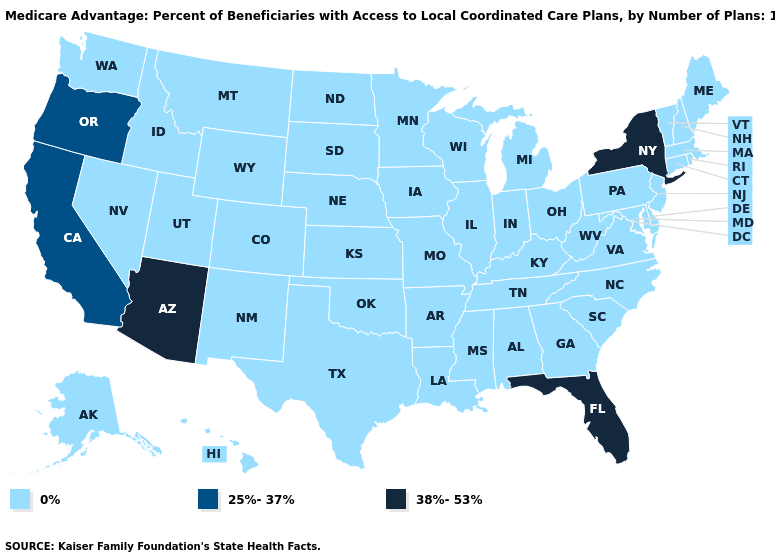Name the states that have a value in the range 38%-53%?
Concise answer only. Arizona, Florida, New York. Among the states that border Nebraska , which have the lowest value?
Write a very short answer. Colorado, Iowa, Kansas, Missouri, South Dakota, Wyoming. What is the value of Oklahoma?
Concise answer only. 0%. Does Washington have a lower value than California?
Quick response, please. Yes. What is the lowest value in states that border Oregon?
Keep it brief. 0%. What is the value of Vermont?
Give a very brief answer. 0%. Name the states that have a value in the range 0%?
Give a very brief answer. Alaska, Alabama, Arkansas, Colorado, Connecticut, Delaware, Georgia, Hawaii, Iowa, Idaho, Illinois, Indiana, Kansas, Kentucky, Louisiana, Massachusetts, Maryland, Maine, Michigan, Minnesota, Missouri, Mississippi, Montana, North Carolina, North Dakota, Nebraska, New Hampshire, New Jersey, New Mexico, Nevada, Ohio, Oklahoma, Pennsylvania, Rhode Island, South Carolina, South Dakota, Tennessee, Texas, Utah, Virginia, Vermont, Washington, Wisconsin, West Virginia, Wyoming. Name the states that have a value in the range 25%-37%?
Be succinct. California, Oregon. What is the highest value in the USA?
Write a very short answer. 38%-53%. Name the states that have a value in the range 0%?
Short answer required. Alaska, Alabama, Arkansas, Colorado, Connecticut, Delaware, Georgia, Hawaii, Iowa, Idaho, Illinois, Indiana, Kansas, Kentucky, Louisiana, Massachusetts, Maryland, Maine, Michigan, Minnesota, Missouri, Mississippi, Montana, North Carolina, North Dakota, Nebraska, New Hampshire, New Jersey, New Mexico, Nevada, Ohio, Oklahoma, Pennsylvania, Rhode Island, South Carolina, South Dakota, Tennessee, Texas, Utah, Virginia, Vermont, Washington, Wisconsin, West Virginia, Wyoming. Which states have the lowest value in the USA?
Be succinct. Alaska, Alabama, Arkansas, Colorado, Connecticut, Delaware, Georgia, Hawaii, Iowa, Idaho, Illinois, Indiana, Kansas, Kentucky, Louisiana, Massachusetts, Maryland, Maine, Michigan, Minnesota, Missouri, Mississippi, Montana, North Carolina, North Dakota, Nebraska, New Hampshire, New Jersey, New Mexico, Nevada, Ohio, Oklahoma, Pennsylvania, Rhode Island, South Carolina, South Dakota, Tennessee, Texas, Utah, Virginia, Vermont, Washington, Wisconsin, West Virginia, Wyoming. What is the value of South Carolina?
Short answer required. 0%. 